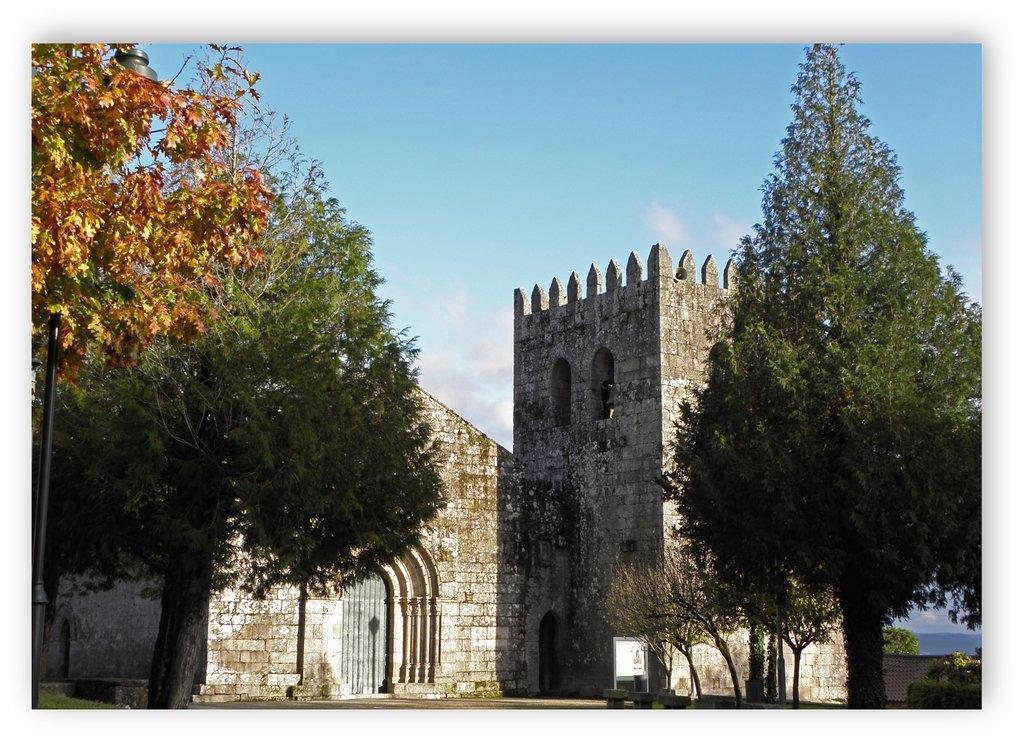Please provide a concise description of this image. In this image I can see there are few trees, a fort and the sky is clear. 